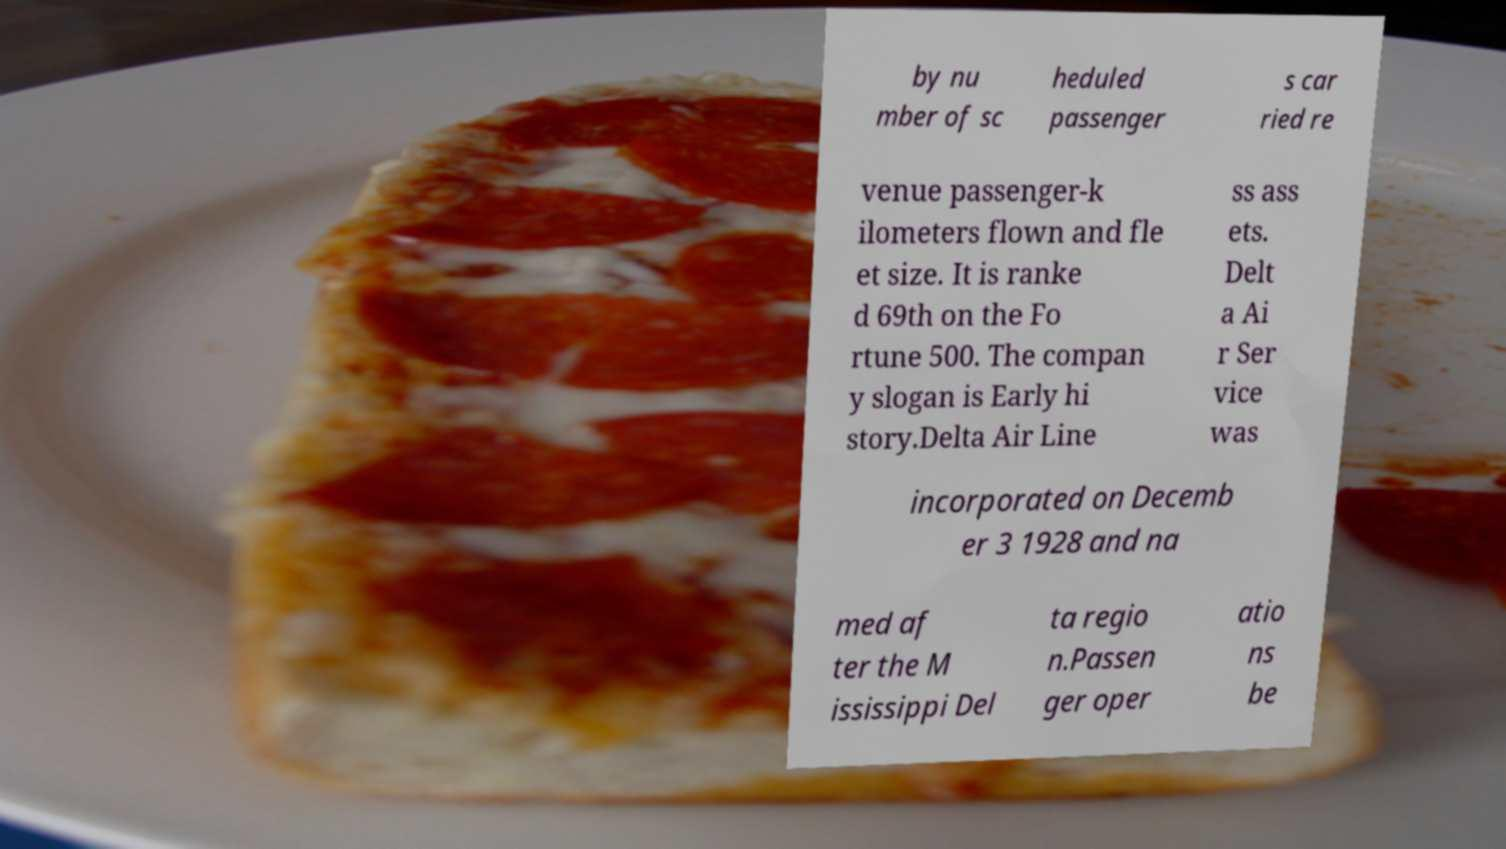What messages or text are displayed in this image? I need them in a readable, typed format. by nu mber of sc heduled passenger s car ried re venue passenger-k ilometers flown and fle et size. It is ranke d 69th on the Fo rtune 500. The compan y slogan is Early hi story.Delta Air Line ss ass ets. Delt a Ai r Ser vice was incorporated on Decemb er 3 1928 and na med af ter the M ississippi Del ta regio n.Passen ger oper atio ns be 